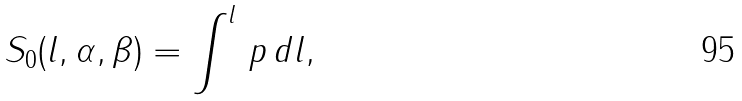<formula> <loc_0><loc_0><loc_500><loc_500>S _ { 0 } ( l , \alpha , \beta ) = \int ^ { l } \, p \, d l ,</formula> 